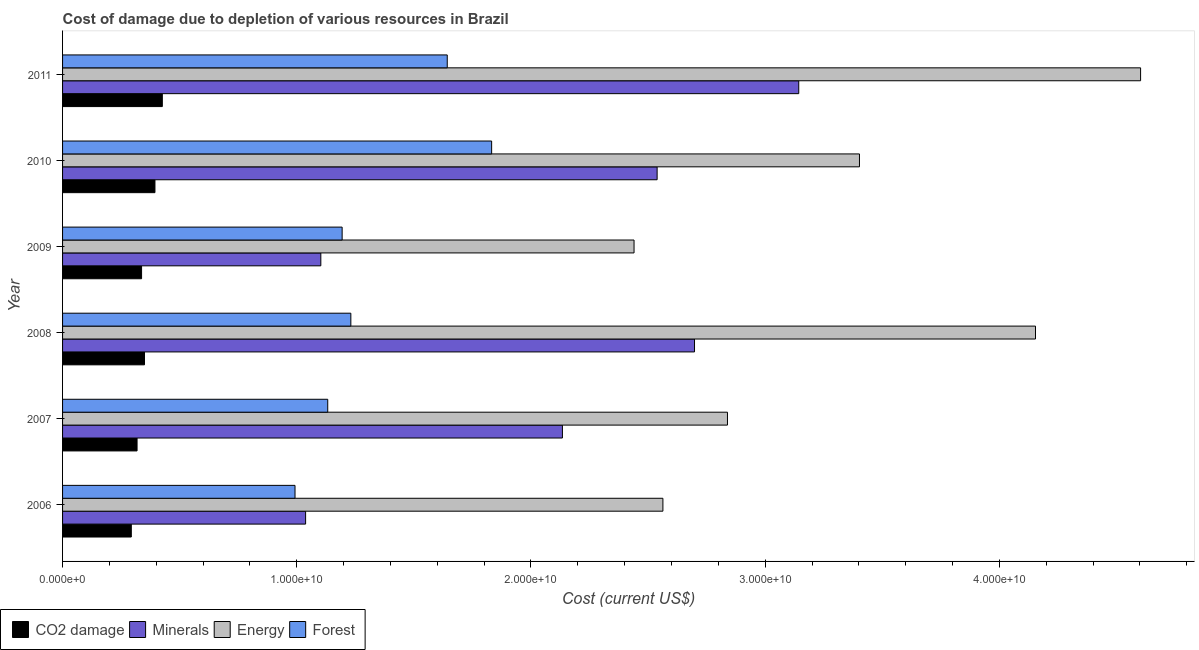How many groups of bars are there?
Give a very brief answer. 6. How many bars are there on the 5th tick from the top?
Make the answer very short. 4. What is the label of the 1st group of bars from the top?
Your answer should be compact. 2011. In how many cases, is the number of bars for a given year not equal to the number of legend labels?
Provide a succinct answer. 0. What is the cost of damage due to depletion of minerals in 2010?
Give a very brief answer. 2.54e+1. Across all years, what is the maximum cost of damage due to depletion of forests?
Offer a very short reply. 1.83e+1. Across all years, what is the minimum cost of damage due to depletion of coal?
Keep it short and to the point. 2.94e+09. In which year was the cost of damage due to depletion of coal maximum?
Your answer should be compact. 2011. In which year was the cost of damage due to depletion of forests minimum?
Your answer should be very brief. 2006. What is the total cost of damage due to depletion of coal in the graph?
Offer a terse response. 2.12e+1. What is the difference between the cost of damage due to depletion of forests in 2007 and that in 2011?
Provide a succinct answer. -5.10e+09. What is the difference between the cost of damage due to depletion of minerals in 2011 and the cost of damage due to depletion of energy in 2006?
Your answer should be compact. 5.80e+09. What is the average cost of damage due to depletion of forests per year?
Offer a very short reply. 1.34e+1. In the year 2010, what is the difference between the cost of damage due to depletion of coal and cost of damage due to depletion of minerals?
Give a very brief answer. -2.14e+1. What is the ratio of the cost of damage due to depletion of forests in 2007 to that in 2011?
Make the answer very short. 0.69. Is the difference between the cost of damage due to depletion of coal in 2007 and 2010 greater than the difference between the cost of damage due to depletion of forests in 2007 and 2010?
Ensure brevity in your answer.  Yes. What is the difference between the highest and the second highest cost of damage due to depletion of minerals?
Offer a very short reply. 4.45e+09. What is the difference between the highest and the lowest cost of damage due to depletion of forests?
Offer a terse response. 8.39e+09. In how many years, is the cost of damage due to depletion of energy greater than the average cost of damage due to depletion of energy taken over all years?
Your response must be concise. 3. Is the sum of the cost of damage due to depletion of coal in 2009 and 2011 greater than the maximum cost of damage due to depletion of energy across all years?
Your response must be concise. No. What does the 2nd bar from the top in 2007 represents?
Your answer should be compact. Energy. What does the 3rd bar from the bottom in 2006 represents?
Ensure brevity in your answer.  Energy. Is it the case that in every year, the sum of the cost of damage due to depletion of coal and cost of damage due to depletion of minerals is greater than the cost of damage due to depletion of energy?
Your response must be concise. No. Are all the bars in the graph horizontal?
Give a very brief answer. Yes. Does the graph contain any zero values?
Your response must be concise. No. Does the graph contain grids?
Your answer should be very brief. No. How many legend labels are there?
Your answer should be very brief. 4. What is the title of the graph?
Keep it short and to the point. Cost of damage due to depletion of various resources in Brazil . Does "Negligence towards children" appear as one of the legend labels in the graph?
Your answer should be compact. No. What is the label or title of the X-axis?
Keep it short and to the point. Cost (current US$). What is the Cost (current US$) in CO2 damage in 2006?
Ensure brevity in your answer.  2.94e+09. What is the Cost (current US$) of Minerals in 2006?
Your answer should be compact. 1.04e+1. What is the Cost (current US$) of Energy in 2006?
Ensure brevity in your answer.  2.56e+1. What is the Cost (current US$) of Forest in 2006?
Your response must be concise. 9.93e+09. What is the Cost (current US$) of CO2 damage in 2007?
Keep it short and to the point. 3.18e+09. What is the Cost (current US$) in Minerals in 2007?
Provide a succinct answer. 2.13e+1. What is the Cost (current US$) of Energy in 2007?
Keep it short and to the point. 2.84e+1. What is the Cost (current US$) of Forest in 2007?
Keep it short and to the point. 1.13e+1. What is the Cost (current US$) in CO2 damage in 2008?
Offer a terse response. 3.50e+09. What is the Cost (current US$) of Minerals in 2008?
Provide a succinct answer. 2.70e+1. What is the Cost (current US$) of Energy in 2008?
Keep it short and to the point. 4.15e+1. What is the Cost (current US$) of Forest in 2008?
Offer a terse response. 1.23e+1. What is the Cost (current US$) in CO2 damage in 2009?
Your answer should be compact. 3.37e+09. What is the Cost (current US$) of Minerals in 2009?
Your response must be concise. 1.10e+1. What is the Cost (current US$) of Energy in 2009?
Provide a succinct answer. 2.44e+1. What is the Cost (current US$) in Forest in 2009?
Make the answer very short. 1.19e+1. What is the Cost (current US$) in CO2 damage in 2010?
Provide a short and direct response. 3.94e+09. What is the Cost (current US$) of Minerals in 2010?
Your answer should be compact. 2.54e+1. What is the Cost (current US$) of Energy in 2010?
Your answer should be very brief. 3.40e+1. What is the Cost (current US$) of Forest in 2010?
Your response must be concise. 1.83e+1. What is the Cost (current US$) of CO2 damage in 2011?
Offer a very short reply. 4.26e+09. What is the Cost (current US$) of Minerals in 2011?
Offer a terse response. 3.14e+1. What is the Cost (current US$) in Energy in 2011?
Your answer should be compact. 4.60e+1. What is the Cost (current US$) in Forest in 2011?
Offer a terse response. 1.64e+1. Across all years, what is the maximum Cost (current US$) of CO2 damage?
Your response must be concise. 4.26e+09. Across all years, what is the maximum Cost (current US$) in Minerals?
Your response must be concise. 3.14e+1. Across all years, what is the maximum Cost (current US$) in Energy?
Offer a very short reply. 4.60e+1. Across all years, what is the maximum Cost (current US$) of Forest?
Offer a terse response. 1.83e+1. Across all years, what is the minimum Cost (current US$) in CO2 damage?
Your response must be concise. 2.94e+09. Across all years, what is the minimum Cost (current US$) of Minerals?
Give a very brief answer. 1.04e+1. Across all years, what is the minimum Cost (current US$) of Energy?
Your answer should be compact. 2.44e+1. Across all years, what is the minimum Cost (current US$) in Forest?
Offer a very short reply. 9.93e+09. What is the total Cost (current US$) of CO2 damage in the graph?
Offer a very short reply. 2.12e+1. What is the total Cost (current US$) in Minerals in the graph?
Offer a very short reply. 1.27e+11. What is the total Cost (current US$) of Energy in the graph?
Provide a succinct answer. 2.00e+11. What is the total Cost (current US$) of Forest in the graph?
Provide a short and direct response. 8.02e+1. What is the difference between the Cost (current US$) of CO2 damage in 2006 and that in 2007?
Keep it short and to the point. -2.46e+08. What is the difference between the Cost (current US$) of Minerals in 2006 and that in 2007?
Your answer should be compact. -1.10e+1. What is the difference between the Cost (current US$) in Energy in 2006 and that in 2007?
Keep it short and to the point. -2.76e+09. What is the difference between the Cost (current US$) of Forest in 2006 and that in 2007?
Ensure brevity in your answer.  -1.40e+09. What is the difference between the Cost (current US$) of CO2 damage in 2006 and that in 2008?
Your answer should be very brief. -5.63e+08. What is the difference between the Cost (current US$) in Minerals in 2006 and that in 2008?
Your answer should be compact. -1.66e+1. What is the difference between the Cost (current US$) of Energy in 2006 and that in 2008?
Make the answer very short. -1.59e+1. What is the difference between the Cost (current US$) in Forest in 2006 and that in 2008?
Provide a short and direct response. -2.38e+09. What is the difference between the Cost (current US$) of CO2 damage in 2006 and that in 2009?
Offer a very short reply. -4.38e+08. What is the difference between the Cost (current US$) of Minerals in 2006 and that in 2009?
Make the answer very short. -6.50e+08. What is the difference between the Cost (current US$) of Energy in 2006 and that in 2009?
Offer a terse response. 1.23e+09. What is the difference between the Cost (current US$) in Forest in 2006 and that in 2009?
Provide a short and direct response. -2.01e+09. What is the difference between the Cost (current US$) of CO2 damage in 2006 and that in 2010?
Provide a succinct answer. -1.01e+09. What is the difference between the Cost (current US$) of Minerals in 2006 and that in 2010?
Provide a short and direct response. -1.50e+1. What is the difference between the Cost (current US$) in Energy in 2006 and that in 2010?
Your response must be concise. -8.39e+09. What is the difference between the Cost (current US$) of Forest in 2006 and that in 2010?
Your answer should be very brief. -8.39e+09. What is the difference between the Cost (current US$) of CO2 damage in 2006 and that in 2011?
Offer a terse response. -1.32e+09. What is the difference between the Cost (current US$) of Minerals in 2006 and that in 2011?
Provide a succinct answer. -2.11e+1. What is the difference between the Cost (current US$) of Energy in 2006 and that in 2011?
Ensure brevity in your answer.  -2.04e+1. What is the difference between the Cost (current US$) in Forest in 2006 and that in 2011?
Keep it short and to the point. -6.50e+09. What is the difference between the Cost (current US$) in CO2 damage in 2007 and that in 2008?
Provide a short and direct response. -3.17e+08. What is the difference between the Cost (current US$) of Minerals in 2007 and that in 2008?
Ensure brevity in your answer.  -5.64e+09. What is the difference between the Cost (current US$) of Energy in 2007 and that in 2008?
Offer a terse response. -1.32e+1. What is the difference between the Cost (current US$) of Forest in 2007 and that in 2008?
Offer a terse response. -9.87e+08. What is the difference between the Cost (current US$) in CO2 damage in 2007 and that in 2009?
Provide a succinct answer. -1.92e+08. What is the difference between the Cost (current US$) in Minerals in 2007 and that in 2009?
Offer a terse response. 1.03e+1. What is the difference between the Cost (current US$) of Energy in 2007 and that in 2009?
Offer a terse response. 3.99e+09. What is the difference between the Cost (current US$) in Forest in 2007 and that in 2009?
Offer a terse response. -6.15e+08. What is the difference between the Cost (current US$) of CO2 damage in 2007 and that in 2010?
Your answer should be compact. -7.64e+08. What is the difference between the Cost (current US$) of Minerals in 2007 and that in 2010?
Provide a short and direct response. -4.04e+09. What is the difference between the Cost (current US$) of Energy in 2007 and that in 2010?
Offer a very short reply. -5.64e+09. What is the difference between the Cost (current US$) in Forest in 2007 and that in 2010?
Provide a short and direct response. -7.00e+09. What is the difference between the Cost (current US$) in CO2 damage in 2007 and that in 2011?
Offer a terse response. -1.08e+09. What is the difference between the Cost (current US$) of Minerals in 2007 and that in 2011?
Provide a short and direct response. -1.01e+1. What is the difference between the Cost (current US$) in Energy in 2007 and that in 2011?
Your response must be concise. -1.76e+1. What is the difference between the Cost (current US$) of Forest in 2007 and that in 2011?
Your answer should be very brief. -5.10e+09. What is the difference between the Cost (current US$) of CO2 damage in 2008 and that in 2009?
Your response must be concise. 1.25e+08. What is the difference between the Cost (current US$) in Minerals in 2008 and that in 2009?
Offer a very short reply. 1.60e+1. What is the difference between the Cost (current US$) in Energy in 2008 and that in 2009?
Provide a succinct answer. 1.71e+1. What is the difference between the Cost (current US$) in Forest in 2008 and that in 2009?
Provide a short and direct response. 3.72e+08. What is the difference between the Cost (current US$) in CO2 damage in 2008 and that in 2010?
Make the answer very short. -4.47e+08. What is the difference between the Cost (current US$) of Minerals in 2008 and that in 2010?
Provide a succinct answer. 1.60e+09. What is the difference between the Cost (current US$) of Energy in 2008 and that in 2010?
Provide a succinct answer. 7.52e+09. What is the difference between the Cost (current US$) in Forest in 2008 and that in 2010?
Ensure brevity in your answer.  -6.01e+09. What is the difference between the Cost (current US$) of CO2 damage in 2008 and that in 2011?
Provide a succinct answer. -7.61e+08. What is the difference between the Cost (current US$) in Minerals in 2008 and that in 2011?
Your response must be concise. -4.45e+09. What is the difference between the Cost (current US$) of Energy in 2008 and that in 2011?
Ensure brevity in your answer.  -4.49e+09. What is the difference between the Cost (current US$) in Forest in 2008 and that in 2011?
Keep it short and to the point. -4.12e+09. What is the difference between the Cost (current US$) in CO2 damage in 2009 and that in 2010?
Provide a short and direct response. -5.71e+08. What is the difference between the Cost (current US$) of Minerals in 2009 and that in 2010?
Offer a terse response. -1.44e+1. What is the difference between the Cost (current US$) in Energy in 2009 and that in 2010?
Provide a succinct answer. -9.62e+09. What is the difference between the Cost (current US$) in Forest in 2009 and that in 2010?
Keep it short and to the point. -6.38e+09. What is the difference between the Cost (current US$) in CO2 damage in 2009 and that in 2011?
Your answer should be very brief. -8.86e+08. What is the difference between the Cost (current US$) of Minerals in 2009 and that in 2011?
Make the answer very short. -2.04e+1. What is the difference between the Cost (current US$) in Energy in 2009 and that in 2011?
Your answer should be compact. -2.16e+1. What is the difference between the Cost (current US$) in Forest in 2009 and that in 2011?
Provide a short and direct response. -4.49e+09. What is the difference between the Cost (current US$) of CO2 damage in 2010 and that in 2011?
Offer a terse response. -3.14e+08. What is the difference between the Cost (current US$) in Minerals in 2010 and that in 2011?
Provide a short and direct response. -6.05e+09. What is the difference between the Cost (current US$) of Energy in 2010 and that in 2011?
Your response must be concise. -1.20e+1. What is the difference between the Cost (current US$) in Forest in 2010 and that in 2011?
Your response must be concise. 1.90e+09. What is the difference between the Cost (current US$) of CO2 damage in 2006 and the Cost (current US$) of Minerals in 2007?
Your answer should be very brief. -1.84e+1. What is the difference between the Cost (current US$) in CO2 damage in 2006 and the Cost (current US$) in Energy in 2007?
Ensure brevity in your answer.  -2.55e+1. What is the difference between the Cost (current US$) in CO2 damage in 2006 and the Cost (current US$) in Forest in 2007?
Offer a very short reply. -8.39e+09. What is the difference between the Cost (current US$) in Minerals in 2006 and the Cost (current US$) in Energy in 2007?
Your answer should be compact. -1.80e+1. What is the difference between the Cost (current US$) in Minerals in 2006 and the Cost (current US$) in Forest in 2007?
Your response must be concise. -9.45e+08. What is the difference between the Cost (current US$) of Energy in 2006 and the Cost (current US$) of Forest in 2007?
Ensure brevity in your answer.  1.43e+1. What is the difference between the Cost (current US$) of CO2 damage in 2006 and the Cost (current US$) of Minerals in 2008?
Provide a short and direct response. -2.40e+1. What is the difference between the Cost (current US$) in CO2 damage in 2006 and the Cost (current US$) in Energy in 2008?
Provide a short and direct response. -3.86e+1. What is the difference between the Cost (current US$) in CO2 damage in 2006 and the Cost (current US$) in Forest in 2008?
Make the answer very short. -9.37e+09. What is the difference between the Cost (current US$) of Minerals in 2006 and the Cost (current US$) of Energy in 2008?
Provide a short and direct response. -3.12e+1. What is the difference between the Cost (current US$) of Minerals in 2006 and the Cost (current US$) of Forest in 2008?
Your answer should be compact. -1.93e+09. What is the difference between the Cost (current US$) in Energy in 2006 and the Cost (current US$) in Forest in 2008?
Provide a short and direct response. 1.33e+1. What is the difference between the Cost (current US$) of CO2 damage in 2006 and the Cost (current US$) of Minerals in 2009?
Offer a terse response. -8.09e+09. What is the difference between the Cost (current US$) of CO2 damage in 2006 and the Cost (current US$) of Energy in 2009?
Offer a very short reply. -2.15e+1. What is the difference between the Cost (current US$) in CO2 damage in 2006 and the Cost (current US$) in Forest in 2009?
Offer a very short reply. -9.00e+09. What is the difference between the Cost (current US$) of Minerals in 2006 and the Cost (current US$) of Energy in 2009?
Ensure brevity in your answer.  -1.40e+1. What is the difference between the Cost (current US$) in Minerals in 2006 and the Cost (current US$) in Forest in 2009?
Provide a short and direct response. -1.56e+09. What is the difference between the Cost (current US$) in Energy in 2006 and the Cost (current US$) in Forest in 2009?
Make the answer very short. 1.37e+1. What is the difference between the Cost (current US$) in CO2 damage in 2006 and the Cost (current US$) in Minerals in 2010?
Keep it short and to the point. -2.25e+1. What is the difference between the Cost (current US$) in CO2 damage in 2006 and the Cost (current US$) in Energy in 2010?
Provide a short and direct response. -3.11e+1. What is the difference between the Cost (current US$) in CO2 damage in 2006 and the Cost (current US$) in Forest in 2010?
Offer a very short reply. -1.54e+1. What is the difference between the Cost (current US$) of Minerals in 2006 and the Cost (current US$) of Energy in 2010?
Your answer should be compact. -2.36e+1. What is the difference between the Cost (current US$) of Minerals in 2006 and the Cost (current US$) of Forest in 2010?
Provide a succinct answer. -7.94e+09. What is the difference between the Cost (current US$) in Energy in 2006 and the Cost (current US$) in Forest in 2010?
Your answer should be compact. 7.31e+09. What is the difference between the Cost (current US$) of CO2 damage in 2006 and the Cost (current US$) of Minerals in 2011?
Ensure brevity in your answer.  -2.85e+1. What is the difference between the Cost (current US$) in CO2 damage in 2006 and the Cost (current US$) in Energy in 2011?
Ensure brevity in your answer.  -4.31e+1. What is the difference between the Cost (current US$) in CO2 damage in 2006 and the Cost (current US$) in Forest in 2011?
Ensure brevity in your answer.  -1.35e+1. What is the difference between the Cost (current US$) of Minerals in 2006 and the Cost (current US$) of Energy in 2011?
Your answer should be very brief. -3.57e+1. What is the difference between the Cost (current US$) of Minerals in 2006 and the Cost (current US$) of Forest in 2011?
Keep it short and to the point. -6.05e+09. What is the difference between the Cost (current US$) in Energy in 2006 and the Cost (current US$) in Forest in 2011?
Ensure brevity in your answer.  9.21e+09. What is the difference between the Cost (current US$) in CO2 damage in 2007 and the Cost (current US$) in Minerals in 2008?
Ensure brevity in your answer.  -2.38e+1. What is the difference between the Cost (current US$) of CO2 damage in 2007 and the Cost (current US$) of Energy in 2008?
Your answer should be very brief. -3.84e+1. What is the difference between the Cost (current US$) in CO2 damage in 2007 and the Cost (current US$) in Forest in 2008?
Ensure brevity in your answer.  -9.13e+09. What is the difference between the Cost (current US$) of Minerals in 2007 and the Cost (current US$) of Energy in 2008?
Ensure brevity in your answer.  -2.02e+1. What is the difference between the Cost (current US$) of Minerals in 2007 and the Cost (current US$) of Forest in 2008?
Provide a short and direct response. 9.03e+09. What is the difference between the Cost (current US$) of Energy in 2007 and the Cost (current US$) of Forest in 2008?
Provide a succinct answer. 1.61e+1. What is the difference between the Cost (current US$) of CO2 damage in 2007 and the Cost (current US$) of Minerals in 2009?
Provide a succinct answer. -7.85e+09. What is the difference between the Cost (current US$) of CO2 damage in 2007 and the Cost (current US$) of Energy in 2009?
Provide a succinct answer. -2.12e+1. What is the difference between the Cost (current US$) of CO2 damage in 2007 and the Cost (current US$) of Forest in 2009?
Ensure brevity in your answer.  -8.76e+09. What is the difference between the Cost (current US$) of Minerals in 2007 and the Cost (current US$) of Energy in 2009?
Your answer should be compact. -3.06e+09. What is the difference between the Cost (current US$) in Minerals in 2007 and the Cost (current US$) in Forest in 2009?
Provide a succinct answer. 9.41e+09. What is the difference between the Cost (current US$) in Energy in 2007 and the Cost (current US$) in Forest in 2009?
Your answer should be very brief. 1.65e+1. What is the difference between the Cost (current US$) of CO2 damage in 2007 and the Cost (current US$) of Minerals in 2010?
Provide a short and direct response. -2.22e+1. What is the difference between the Cost (current US$) in CO2 damage in 2007 and the Cost (current US$) in Energy in 2010?
Offer a very short reply. -3.08e+1. What is the difference between the Cost (current US$) of CO2 damage in 2007 and the Cost (current US$) of Forest in 2010?
Your answer should be very brief. -1.51e+1. What is the difference between the Cost (current US$) in Minerals in 2007 and the Cost (current US$) in Energy in 2010?
Your response must be concise. -1.27e+1. What is the difference between the Cost (current US$) of Minerals in 2007 and the Cost (current US$) of Forest in 2010?
Offer a terse response. 3.02e+09. What is the difference between the Cost (current US$) in Energy in 2007 and the Cost (current US$) in Forest in 2010?
Keep it short and to the point. 1.01e+1. What is the difference between the Cost (current US$) of CO2 damage in 2007 and the Cost (current US$) of Minerals in 2011?
Make the answer very short. -2.83e+1. What is the difference between the Cost (current US$) of CO2 damage in 2007 and the Cost (current US$) of Energy in 2011?
Offer a very short reply. -4.28e+1. What is the difference between the Cost (current US$) in CO2 damage in 2007 and the Cost (current US$) in Forest in 2011?
Ensure brevity in your answer.  -1.32e+1. What is the difference between the Cost (current US$) of Minerals in 2007 and the Cost (current US$) of Energy in 2011?
Your response must be concise. -2.47e+1. What is the difference between the Cost (current US$) in Minerals in 2007 and the Cost (current US$) in Forest in 2011?
Keep it short and to the point. 4.92e+09. What is the difference between the Cost (current US$) of Energy in 2007 and the Cost (current US$) of Forest in 2011?
Offer a terse response. 1.20e+1. What is the difference between the Cost (current US$) of CO2 damage in 2008 and the Cost (current US$) of Minerals in 2009?
Make the answer very short. -7.53e+09. What is the difference between the Cost (current US$) of CO2 damage in 2008 and the Cost (current US$) of Energy in 2009?
Offer a terse response. -2.09e+1. What is the difference between the Cost (current US$) of CO2 damage in 2008 and the Cost (current US$) of Forest in 2009?
Your answer should be very brief. -8.44e+09. What is the difference between the Cost (current US$) of Minerals in 2008 and the Cost (current US$) of Energy in 2009?
Keep it short and to the point. 2.58e+09. What is the difference between the Cost (current US$) in Minerals in 2008 and the Cost (current US$) in Forest in 2009?
Ensure brevity in your answer.  1.50e+1. What is the difference between the Cost (current US$) of Energy in 2008 and the Cost (current US$) of Forest in 2009?
Provide a succinct answer. 2.96e+1. What is the difference between the Cost (current US$) in CO2 damage in 2008 and the Cost (current US$) in Minerals in 2010?
Give a very brief answer. -2.19e+1. What is the difference between the Cost (current US$) in CO2 damage in 2008 and the Cost (current US$) in Energy in 2010?
Your response must be concise. -3.05e+1. What is the difference between the Cost (current US$) of CO2 damage in 2008 and the Cost (current US$) of Forest in 2010?
Your answer should be compact. -1.48e+1. What is the difference between the Cost (current US$) in Minerals in 2008 and the Cost (current US$) in Energy in 2010?
Provide a succinct answer. -7.04e+09. What is the difference between the Cost (current US$) in Minerals in 2008 and the Cost (current US$) in Forest in 2010?
Offer a very short reply. 8.66e+09. What is the difference between the Cost (current US$) in Energy in 2008 and the Cost (current US$) in Forest in 2010?
Your response must be concise. 2.32e+1. What is the difference between the Cost (current US$) in CO2 damage in 2008 and the Cost (current US$) in Minerals in 2011?
Keep it short and to the point. -2.79e+1. What is the difference between the Cost (current US$) of CO2 damage in 2008 and the Cost (current US$) of Energy in 2011?
Provide a short and direct response. -4.25e+1. What is the difference between the Cost (current US$) of CO2 damage in 2008 and the Cost (current US$) of Forest in 2011?
Offer a terse response. -1.29e+1. What is the difference between the Cost (current US$) of Minerals in 2008 and the Cost (current US$) of Energy in 2011?
Provide a short and direct response. -1.90e+1. What is the difference between the Cost (current US$) of Minerals in 2008 and the Cost (current US$) of Forest in 2011?
Offer a terse response. 1.06e+1. What is the difference between the Cost (current US$) of Energy in 2008 and the Cost (current US$) of Forest in 2011?
Provide a succinct answer. 2.51e+1. What is the difference between the Cost (current US$) of CO2 damage in 2009 and the Cost (current US$) of Minerals in 2010?
Make the answer very short. -2.20e+1. What is the difference between the Cost (current US$) in CO2 damage in 2009 and the Cost (current US$) in Energy in 2010?
Offer a very short reply. -3.07e+1. What is the difference between the Cost (current US$) of CO2 damage in 2009 and the Cost (current US$) of Forest in 2010?
Offer a terse response. -1.49e+1. What is the difference between the Cost (current US$) of Minerals in 2009 and the Cost (current US$) of Energy in 2010?
Give a very brief answer. -2.30e+1. What is the difference between the Cost (current US$) in Minerals in 2009 and the Cost (current US$) in Forest in 2010?
Your answer should be compact. -7.29e+09. What is the difference between the Cost (current US$) in Energy in 2009 and the Cost (current US$) in Forest in 2010?
Ensure brevity in your answer.  6.08e+09. What is the difference between the Cost (current US$) in CO2 damage in 2009 and the Cost (current US$) in Minerals in 2011?
Offer a terse response. -2.81e+1. What is the difference between the Cost (current US$) in CO2 damage in 2009 and the Cost (current US$) in Energy in 2011?
Your answer should be compact. -4.27e+1. What is the difference between the Cost (current US$) of CO2 damage in 2009 and the Cost (current US$) of Forest in 2011?
Your answer should be very brief. -1.31e+1. What is the difference between the Cost (current US$) in Minerals in 2009 and the Cost (current US$) in Energy in 2011?
Provide a succinct answer. -3.50e+1. What is the difference between the Cost (current US$) of Minerals in 2009 and the Cost (current US$) of Forest in 2011?
Your response must be concise. -5.40e+09. What is the difference between the Cost (current US$) of Energy in 2009 and the Cost (current US$) of Forest in 2011?
Provide a succinct answer. 7.98e+09. What is the difference between the Cost (current US$) of CO2 damage in 2010 and the Cost (current US$) of Minerals in 2011?
Your answer should be very brief. -2.75e+1. What is the difference between the Cost (current US$) of CO2 damage in 2010 and the Cost (current US$) of Energy in 2011?
Offer a very short reply. -4.21e+1. What is the difference between the Cost (current US$) in CO2 damage in 2010 and the Cost (current US$) in Forest in 2011?
Ensure brevity in your answer.  -1.25e+1. What is the difference between the Cost (current US$) of Minerals in 2010 and the Cost (current US$) of Energy in 2011?
Give a very brief answer. -2.06e+1. What is the difference between the Cost (current US$) in Minerals in 2010 and the Cost (current US$) in Forest in 2011?
Offer a terse response. 8.96e+09. What is the difference between the Cost (current US$) of Energy in 2010 and the Cost (current US$) of Forest in 2011?
Provide a succinct answer. 1.76e+1. What is the average Cost (current US$) of CO2 damage per year?
Offer a terse response. 3.53e+09. What is the average Cost (current US$) of Minerals per year?
Offer a terse response. 2.11e+1. What is the average Cost (current US$) in Energy per year?
Provide a short and direct response. 3.33e+1. What is the average Cost (current US$) in Forest per year?
Make the answer very short. 1.34e+1. In the year 2006, what is the difference between the Cost (current US$) of CO2 damage and Cost (current US$) of Minerals?
Offer a terse response. -7.44e+09. In the year 2006, what is the difference between the Cost (current US$) in CO2 damage and Cost (current US$) in Energy?
Ensure brevity in your answer.  -2.27e+1. In the year 2006, what is the difference between the Cost (current US$) of CO2 damage and Cost (current US$) of Forest?
Provide a succinct answer. -6.99e+09. In the year 2006, what is the difference between the Cost (current US$) in Minerals and Cost (current US$) in Energy?
Keep it short and to the point. -1.53e+1. In the year 2006, what is the difference between the Cost (current US$) of Minerals and Cost (current US$) of Forest?
Provide a short and direct response. 4.52e+08. In the year 2006, what is the difference between the Cost (current US$) of Energy and Cost (current US$) of Forest?
Keep it short and to the point. 1.57e+1. In the year 2007, what is the difference between the Cost (current US$) of CO2 damage and Cost (current US$) of Minerals?
Make the answer very short. -1.82e+1. In the year 2007, what is the difference between the Cost (current US$) of CO2 damage and Cost (current US$) of Energy?
Give a very brief answer. -2.52e+1. In the year 2007, what is the difference between the Cost (current US$) of CO2 damage and Cost (current US$) of Forest?
Provide a succinct answer. -8.14e+09. In the year 2007, what is the difference between the Cost (current US$) in Minerals and Cost (current US$) in Energy?
Give a very brief answer. -7.05e+09. In the year 2007, what is the difference between the Cost (current US$) in Minerals and Cost (current US$) in Forest?
Give a very brief answer. 1.00e+1. In the year 2007, what is the difference between the Cost (current US$) of Energy and Cost (current US$) of Forest?
Keep it short and to the point. 1.71e+1. In the year 2008, what is the difference between the Cost (current US$) of CO2 damage and Cost (current US$) of Minerals?
Give a very brief answer. -2.35e+1. In the year 2008, what is the difference between the Cost (current US$) in CO2 damage and Cost (current US$) in Energy?
Give a very brief answer. -3.80e+1. In the year 2008, what is the difference between the Cost (current US$) of CO2 damage and Cost (current US$) of Forest?
Offer a terse response. -8.81e+09. In the year 2008, what is the difference between the Cost (current US$) of Minerals and Cost (current US$) of Energy?
Provide a short and direct response. -1.46e+1. In the year 2008, what is the difference between the Cost (current US$) of Minerals and Cost (current US$) of Forest?
Ensure brevity in your answer.  1.47e+1. In the year 2008, what is the difference between the Cost (current US$) of Energy and Cost (current US$) of Forest?
Your response must be concise. 2.92e+1. In the year 2009, what is the difference between the Cost (current US$) in CO2 damage and Cost (current US$) in Minerals?
Your answer should be very brief. -7.65e+09. In the year 2009, what is the difference between the Cost (current US$) of CO2 damage and Cost (current US$) of Energy?
Provide a succinct answer. -2.10e+1. In the year 2009, what is the difference between the Cost (current US$) in CO2 damage and Cost (current US$) in Forest?
Offer a very short reply. -8.56e+09. In the year 2009, what is the difference between the Cost (current US$) of Minerals and Cost (current US$) of Energy?
Your answer should be compact. -1.34e+1. In the year 2009, what is the difference between the Cost (current US$) in Minerals and Cost (current US$) in Forest?
Provide a succinct answer. -9.10e+08. In the year 2009, what is the difference between the Cost (current US$) in Energy and Cost (current US$) in Forest?
Your answer should be compact. 1.25e+1. In the year 2010, what is the difference between the Cost (current US$) of CO2 damage and Cost (current US$) of Minerals?
Your answer should be compact. -2.14e+1. In the year 2010, what is the difference between the Cost (current US$) of CO2 damage and Cost (current US$) of Energy?
Your answer should be very brief. -3.01e+1. In the year 2010, what is the difference between the Cost (current US$) in CO2 damage and Cost (current US$) in Forest?
Keep it short and to the point. -1.44e+1. In the year 2010, what is the difference between the Cost (current US$) of Minerals and Cost (current US$) of Energy?
Your answer should be very brief. -8.64e+09. In the year 2010, what is the difference between the Cost (current US$) in Minerals and Cost (current US$) in Forest?
Your response must be concise. 7.07e+09. In the year 2010, what is the difference between the Cost (current US$) in Energy and Cost (current US$) in Forest?
Provide a short and direct response. 1.57e+1. In the year 2011, what is the difference between the Cost (current US$) in CO2 damage and Cost (current US$) in Minerals?
Provide a short and direct response. -2.72e+1. In the year 2011, what is the difference between the Cost (current US$) in CO2 damage and Cost (current US$) in Energy?
Make the answer very short. -4.18e+1. In the year 2011, what is the difference between the Cost (current US$) in CO2 damage and Cost (current US$) in Forest?
Offer a terse response. -1.22e+1. In the year 2011, what is the difference between the Cost (current US$) of Minerals and Cost (current US$) of Energy?
Ensure brevity in your answer.  -1.46e+1. In the year 2011, what is the difference between the Cost (current US$) of Minerals and Cost (current US$) of Forest?
Offer a very short reply. 1.50e+1. In the year 2011, what is the difference between the Cost (current US$) of Energy and Cost (current US$) of Forest?
Your answer should be compact. 2.96e+1. What is the ratio of the Cost (current US$) in CO2 damage in 2006 to that in 2007?
Your answer should be very brief. 0.92. What is the ratio of the Cost (current US$) in Minerals in 2006 to that in 2007?
Make the answer very short. 0.49. What is the ratio of the Cost (current US$) of Energy in 2006 to that in 2007?
Make the answer very short. 0.9. What is the ratio of the Cost (current US$) in Forest in 2006 to that in 2007?
Offer a terse response. 0.88. What is the ratio of the Cost (current US$) of CO2 damage in 2006 to that in 2008?
Keep it short and to the point. 0.84. What is the ratio of the Cost (current US$) in Minerals in 2006 to that in 2008?
Your answer should be compact. 0.38. What is the ratio of the Cost (current US$) of Energy in 2006 to that in 2008?
Your answer should be compact. 0.62. What is the ratio of the Cost (current US$) in Forest in 2006 to that in 2008?
Your response must be concise. 0.81. What is the ratio of the Cost (current US$) of CO2 damage in 2006 to that in 2009?
Your answer should be very brief. 0.87. What is the ratio of the Cost (current US$) of Minerals in 2006 to that in 2009?
Provide a succinct answer. 0.94. What is the ratio of the Cost (current US$) of Energy in 2006 to that in 2009?
Your answer should be very brief. 1.05. What is the ratio of the Cost (current US$) in Forest in 2006 to that in 2009?
Your answer should be compact. 0.83. What is the ratio of the Cost (current US$) of CO2 damage in 2006 to that in 2010?
Keep it short and to the point. 0.74. What is the ratio of the Cost (current US$) of Minerals in 2006 to that in 2010?
Ensure brevity in your answer.  0.41. What is the ratio of the Cost (current US$) in Energy in 2006 to that in 2010?
Offer a terse response. 0.75. What is the ratio of the Cost (current US$) of Forest in 2006 to that in 2010?
Offer a very short reply. 0.54. What is the ratio of the Cost (current US$) in CO2 damage in 2006 to that in 2011?
Your response must be concise. 0.69. What is the ratio of the Cost (current US$) in Minerals in 2006 to that in 2011?
Offer a terse response. 0.33. What is the ratio of the Cost (current US$) of Energy in 2006 to that in 2011?
Offer a very short reply. 0.56. What is the ratio of the Cost (current US$) of Forest in 2006 to that in 2011?
Keep it short and to the point. 0.6. What is the ratio of the Cost (current US$) in CO2 damage in 2007 to that in 2008?
Give a very brief answer. 0.91. What is the ratio of the Cost (current US$) in Minerals in 2007 to that in 2008?
Provide a succinct answer. 0.79. What is the ratio of the Cost (current US$) in Energy in 2007 to that in 2008?
Your answer should be compact. 0.68. What is the ratio of the Cost (current US$) in Forest in 2007 to that in 2008?
Make the answer very short. 0.92. What is the ratio of the Cost (current US$) in CO2 damage in 2007 to that in 2009?
Make the answer very short. 0.94. What is the ratio of the Cost (current US$) in Minerals in 2007 to that in 2009?
Keep it short and to the point. 1.94. What is the ratio of the Cost (current US$) of Energy in 2007 to that in 2009?
Offer a very short reply. 1.16. What is the ratio of the Cost (current US$) of Forest in 2007 to that in 2009?
Offer a terse response. 0.95. What is the ratio of the Cost (current US$) of CO2 damage in 2007 to that in 2010?
Give a very brief answer. 0.81. What is the ratio of the Cost (current US$) in Minerals in 2007 to that in 2010?
Provide a short and direct response. 0.84. What is the ratio of the Cost (current US$) of Energy in 2007 to that in 2010?
Offer a terse response. 0.83. What is the ratio of the Cost (current US$) in Forest in 2007 to that in 2010?
Keep it short and to the point. 0.62. What is the ratio of the Cost (current US$) of CO2 damage in 2007 to that in 2011?
Your answer should be compact. 0.75. What is the ratio of the Cost (current US$) of Minerals in 2007 to that in 2011?
Ensure brevity in your answer.  0.68. What is the ratio of the Cost (current US$) of Energy in 2007 to that in 2011?
Make the answer very short. 0.62. What is the ratio of the Cost (current US$) in Forest in 2007 to that in 2011?
Provide a short and direct response. 0.69. What is the ratio of the Cost (current US$) in CO2 damage in 2008 to that in 2009?
Offer a very short reply. 1.04. What is the ratio of the Cost (current US$) of Minerals in 2008 to that in 2009?
Provide a succinct answer. 2.45. What is the ratio of the Cost (current US$) in Energy in 2008 to that in 2009?
Provide a succinct answer. 1.7. What is the ratio of the Cost (current US$) in Forest in 2008 to that in 2009?
Provide a short and direct response. 1.03. What is the ratio of the Cost (current US$) in CO2 damage in 2008 to that in 2010?
Give a very brief answer. 0.89. What is the ratio of the Cost (current US$) in Minerals in 2008 to that in 2010?
Your answer should be very brief. 1.06. What is the ratio of the Cost (current US$) in Energy in 2008 to that in 2010?
Your answer should be compact. 1.22. What is the ratio of the Cost (current US$) of Forest in 2008 to that in 2010?
Your answer should be compact. 0.67. What is the ratio of the Cost (current US$) in CO2 damage in 2008 to that in 2011?
Your answer should be compact. 0.82. What is the ratio of the Cost (current US$) of Minerals in 2008 to that in 2011?
Your response must be concise. 0.86. What is the ratio of the Cost (current US$) in Energy in 2008 to that in 2011?
Provide a short and direct response. 0.9. What is the ratio of the Cost (current US$) of Forest in 2008 to that in 2011?
Keep it short and to the point. 0.75. What is the ratio of the Cost (current US$) in CO2 damage in 2009 to that in 2010?
Provide a succinct answer. 0.86. What is the ratio of the Cost (current US$) in Minerals in 2009 to that in 2010?
Ensure brevity in your answer.  0.43. What is the ratio of the Cost (current US$) in Energy in 2009 to that in 2010?
Your answer should be very brief. 0.72. What is the ratio of the Cost (current US$) of Forest in 2009 to that in 2010?
Your answer should be compact. 0.65. What is the ratio of the Cost (current US$) of CO2 damage in 2009 to that in 2011?
Ensure brevity in your answer.  0.79. What is the ratio of the Cost (current US$) of Minerals in 2009 to that in 2011?
Ensure brevity in your answer.  0.35. What is the ratio of the Cost (current US$) in Energy in 2009 to that in 2011?
Your answer should be very brief. 0.53. What is the ratio of the Cost (current US$) in Forest in 2009 to that in 2011?
Offer a terse response. 0.73. What is the ratio of the Cost (current US$) in CO2 damage in 2010 to that in 2011?
Your answer should be very brief. 0.93. What is the ratio of the Cost (current US$) in Minerals in 2010 to that in 2011?
Offer a terse response. 0.81. What is the ratio of the Cost (current US$) of Energy in 2010 to that in 2011?
Your answer should be very brief. 0.74. What is the ratio of the Cost (current US$) in Forest in 2010 to that in 2011?
Your answer should be compact. 1.12. What is the difference between the highest and the second highest Cost (current US$) of CO2 damage?
Provide a short and direct response. 3.14e+08. What is the difference between the highest and the second highest Cost (current US$) of Minerals?
Keep it short and to the point. 4.45e+09. What is the difference between the highest and the second highest Cost (current US$) in Energy?
Your response must be concise. 4.49e+09. What is the difference between the highest and the second highest Cost (current US$) in Forest?
Make the answer very short. 1.90e+09. What is the difference between the highest and the lowest Cost (current US$) in CO2 damage?
Give a very brief answer. 1.32e+09. What is the difference between the highest and the lowest Cost (current US$) in Minerals?
Your answer should be very brief. 2.11e+1. What is the difference between the highest and the lowest Cost (current US$) of Energy?
Your response must be concise. 2.16e+1. What is the difference between the highest and the lowest Cost (current US$) of Forest?
Ensure brevity in your answer.  8.39e+09. 